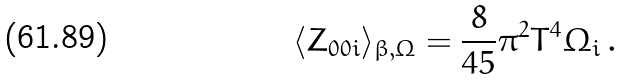Convert formula to latex. <formula><loc_0><loc_0><loc_500><loc_500>\langle Z _ { 0 0 i } \rangle _ { \beta , \Omega } = \frac { 8 } { 4 5 } \pi ^ { 2 } T ^ { 4 } \Omega _ { i } \, .</formula> 